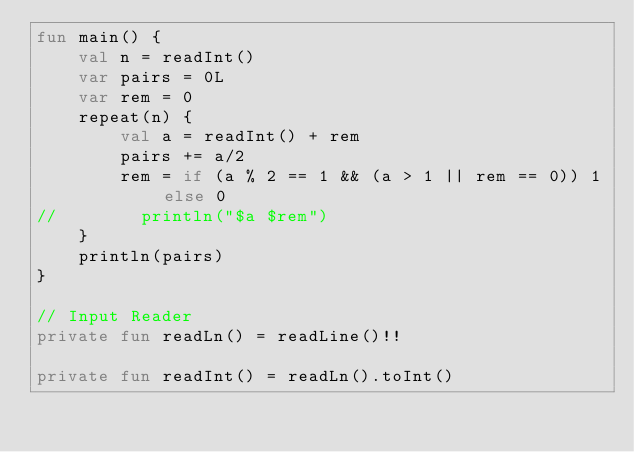<code> <loc_0><loc_0><loc_500><loc_500><_Kotlin_>fun main() {
    val n = readInt()
    var pairs = 0L
    var rem = 0
    repeat(n) {
        val a = readInt() + rem
        pairs += a/2
        rem = if (a % 2 == 1 && (a > 1 || rem == 0)) 1 else 0
//        println("$a $rem")
    }
    println(pairs)
}

// Input Reader
private fun readLn() = readLine()!!

private fun readInt() = readLn().toInt()</code> 